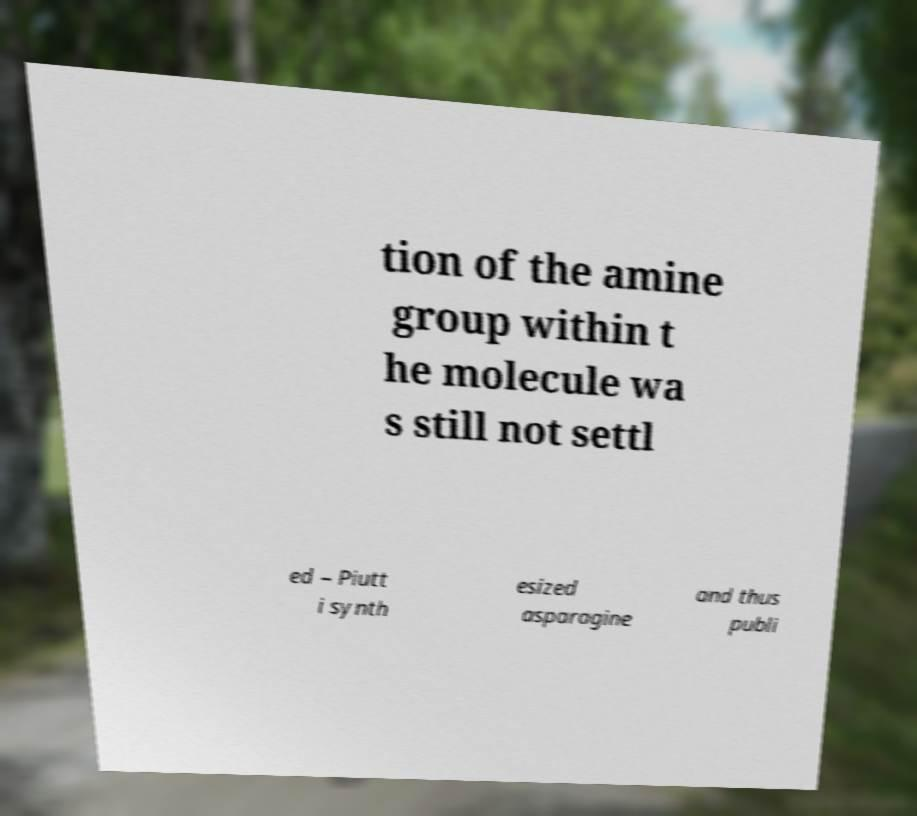There's text embedded in this image that I need extracted. Can you transcribe it verbatim? tion of the amine group within t he molecule wa s still not settl ed – Piutt i synth esized asparagine and thus publi 